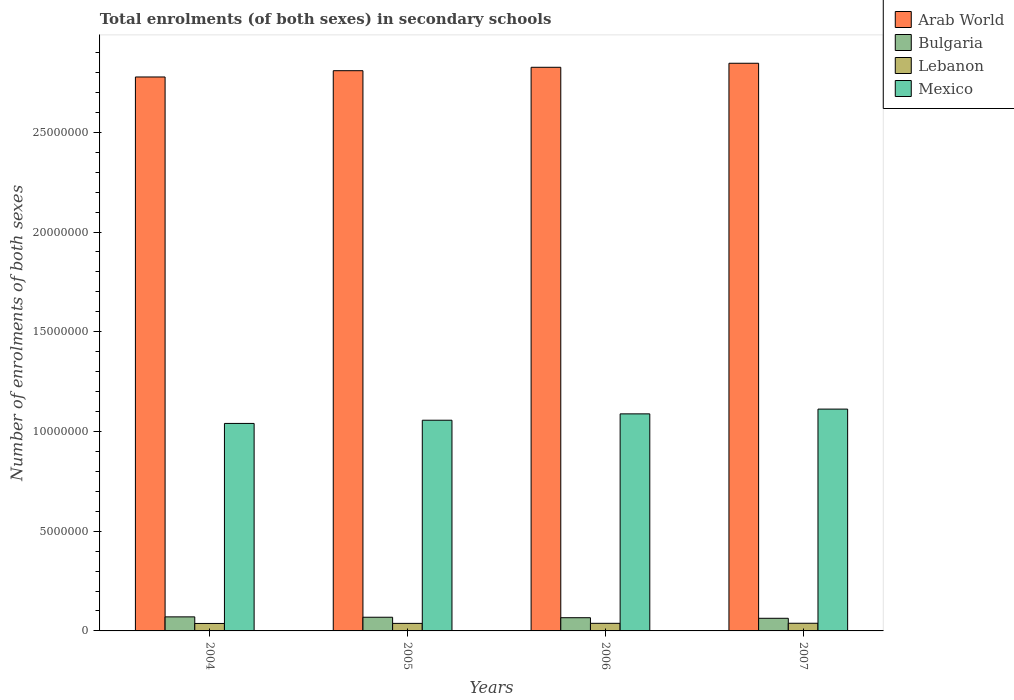How many different coloured bars are there?
Give a very brief answer. 4. How many groups of bars are there?
Ensure brevity in your answer.  4. Are the number of bars per tick equal to the number of legend labels?
Your response must be concise. Yes. What is the number of enrolments in secondary schools in Bulgaria in 2007?
Provide a succinct answer. 6.33e+05. Across all years, what is the maximum number of enrolments in secondary schools in Lebanon?
Your answer should be very brief. 3.84e+05. Across all years, what is the minimum number of enrolments in secondary schools in Lebanon?
Make the answer very short. 3.74e+05. In which year was the number of enrolments in secondary schools in Lebanon maximum?
Provide a short and direct response. 2007. What is the total number of enrolments in secondary schools in Bulgaria in the graph?
Offer a terse response. 2.69e+06. What is the difference between the number of enrolments in secondary schools in Lebanon in 2006 and that in 2007?
Your answer should be compact. -2696. What is the difference between the number of enrolments in secondary schools in Bulgaria in 2007 and the number of enrolments in secondary schools in Arab World in 2004?
Offer a terse response. -2.71e+07. What is the average number of enrolments in secondary schools in Lebanon per year?
Provide a succinct answer. 3.79e+05. In the year 2006, what is the difference between the number of enrolments in secondary schools in Lebanon and number of enrolments in secondary schools in Bulgaria?
Your answer should be compact. -2.81e+05. In how many years, is the number of enrolments in secondary schools in Bulgaria greater than 19000000?
Provide a succinct answer. 0. What is the ratio of the number of enrolments in secondary schools in Arab World in 2004 to that in 2005?
Your answer should be very brief. 0.99. Is the difference between the number of enrolments in secondary schools in Lebanon in 2006 and 2007 greater than the difference between the number of enrolments in secondary schools in Bulgaria in 2006 and 2007?
Make the answer very short. No. What is the difference between the highest and the second highest number of enrolments in secondary schools in Mexico?
Your answer should be very brief. 2.39e+05. What is the difference between the highest and the lowest number of enrolments in secondary schools in Mexico?
Your response must be concise. 7.18e+05. Is it the case that in every year, the sum of the number of enrolments in secondary schools in Arab World and number of enrolments in secondary schools in Bulgaria is greater than the sum of number of enrolments in secondary schools in Mexico and number of enrolments in secondary schools in Lebanon?
Keep it short and to the point. Yes. What does the 1st bar from the right in 2004 represents?
Give a very brief answer. Mexico. What is the difference between two consecutive major ticks on the Y-axis?
Offer a terse response. 5.00e+06. How many legend labels are there?
Your answer should be compact. 4. How are the legend labels stacked?
Provide a succinct answer. Vertical. What is the title of the graph?
Provide a succinct answer. Total enrolments (of both sexes) in secondary schools. Does "Australia" appear as one of the legend labels in the graph?
Keep it short and to the point. No. What is the label or title of the X-axis?
Ensure brevity in your answer.  Years. What is the label or title of the Y-axis?
Give a very brief answer. Number of enrolments of both sexes. What is the Number of enrolments of both sexes in Arab World in 2004?
Your response must be concise. 2.78e+07. What is the Number of enrolments of both sexes in Bulgaria in 2004?
Your response must be concise. 7.05e+05. What is the Number of enrolments of both sexes in Lebanon in 2004?
Provide a succinct answer. 3.74e+05. What is the Number of enrolments of both sexes in Mexico in 2004?
Offer a terse response. 1.04e+07. What is the Number of enrolments of both sexes of Arab World in 2005?
Your response must be concise. 2.81e+07. What is the Number of enrolments of both sexes in Bulgaria in 2005?
Make the answer very short. 6.86e+05. What is the Number of enrolments of both sexes of Lebanon in 2005?
Ensure brevity in your answer.  3.78e+05. What is the Number of enrolments of both sexes in Mexico in 2005?
Offer a terse response. 1.06e+07. What is the Number of enrolments of both sexes of Arab World in 2006?
Your answer should be very brief. 2.83e+07. What is the Number of enrolments of both sexes of Bulgaria in 2006?
Make the answer very short. 6.63e+05. What is the Number of enrolments of both sexes in Lebanon in 2006?
Provide a succinct answer. 3.81e+05. What is the Number of enrolments of both sexes of Mexico in 2006?
Your answer should be compact. 1.09e+07. What is the Number of enrolments of both sexes of Arab World in 2007?
Make the answer very short. 2.85e+07. What is the Number of enrolments of both sexes in Bulgaria in 2007?
Keep it short and to the point. 6.33e+05. What is the Number of enrolments of both sexes in Lebanon in 2007?
Provide a short and direct response. 3.84e+05. What is the Number of enrolments of both sexes in Mexico in 2007?
Provide a short and direct response. 1.11e+07. Across all years, what is the maximum Number of enrolments of both sexes of Arab World?
Make the answer very short. 2.85e+07. Across all years, what is the maximum Number of enrolments of both sexes in Bulgaria?
Give a very brief answer. 7.05e+05. Across all years, what is the maximum Number of enrolments of both sexes in Lebanon?
Ensure brevity in your answer.  3.84e+05. Across all years, what is the maximum Number of enrolments of both sexes in Mexico?
Keep it short and to the point. 1.11e+07. Across all years, what is the minimum Number of enrolments of both sexes of Arab World?
Give a very brief answer. 2.78e+07. Across all years, what is the minimum Number of enrolments of both sexes in Bulgaria?
Ensure brevity in your answer.  6.33e+05. Across all years, what is the minimum Number of enrolments of both sexes of Lebanon?
Offer a terse response. 3.74e+05. Across all years, what is the minimum Number of enrolments of both sexes of Mexico?
Keep it short and to the point. 1.04e+07. What is the total Number of enrolments of both sexes in Arab World in the graph?
Offer a terse response. 1.13e+08. What is the total Number of enrolments of both sexes of Bulgaria in the graph?
Your answer should be very brief. 2.69e+06. What is the total Number of enrolments of both sexes of Lebanon in the graph?
Your answer should be very brief. 1.52e+06. What is the total Number of enrolments of both sexes of Mexico in the graph?
Your answer should be compact. 4.30e+07. What is the difference between the Number of enrolments of both sexes of Arab World in 2004 and that in 2005?
Offer a very short reply. -3.15e+05. What is the difference between the Number of enrolments of both sexes in Bulgaria in 2004 and that in 2005?
Your answer should be compact. 1.90e+04. What is the difference between the Number of enrolments of both sexes in Lebanon in 2004 and that in 2005?
Give a very brief answer. -3838. What is the difference between the Number of enrolments of both sexes in Mexico in 2004 and that in 2005?
Offer a very short reply. -1.61e+05. What is the difference between the Number of enrolments of both sexes of Arab World in 2004 and that in 2006?
Offer a very short reply. -4.86e+05. What is the difference between the Number of enrolments of both sexes in Bulgaria in 2004 and that in 2006?
Provide a succinct answer. 4.22e+04. What is the difference between the Number of enrolments of both sexes in Lebanon in 2004 and that in 2006?
Provide a short and direct response. -7414. What is the difference between the Number of enrolments of both sexes of Mexico in 2004 and that in 2006?
Offer a terse response. -4.80e+05. What is the difference between the Number of enrolments of both sexes of Arab World in 2004 and that in 2007?
Your response must be concise. -6.88e+05. What is the difference between the Number of enrolments of both sexes of Bulgaria in 2004 and that in 2007?
Your response must be concise. 7.13e+04. What is the difference between the Number of enrolments of both sexes of Lebanon in 2004 and that in 2007?
Your response must be concise. -1.01e+04. What is the difference between the Number of enrolments of both sexes in Mexico in 2004 and that in 2007?
Provide a succinct answer. -7.18e+05. What is the difference between the Number of enrolments of both sexes of Arab World in 2005 and that in 2006?
Ensure brevity in your answer.  -1.70e+05. What is the difference between the Number of enrolments of both sexes in Bulgaria in 2005 and that in 2006?
Provide a succinct answer. 2.31e+04. What is the difference between the Number of enrolments of both sexes of Lebanon in 2005 and that in 2006?
Give a very brief answer. -3576. What is the difference between the Number of enrolments of both sexes of Mexico in 2005 and that in 2006?
Ensure brevity in your answer.  -3.19e+05. What is the difference between the Number of enrolments of both sexes of Arab World in 2005 and that in 2007?
Ensure brevity in your answer.  -3.73e+05. What is the difference between the Number of enrolments of both sexes of Bulgaria in 2005 and that in 2007?
Provide a succinct answer. 5.23e+04. What is the difference between the Number of enrolments of both sexes in Lebanon in 2005 and that in 2007?
Keep it short and to the point. -6272. What is the difference between the Number of enrolments of both sexes in Mexico in 2005 and that in 2007?
Your response must be concise. -5.58e+05. What is the difference between the Number of enrolments of both sexes of Arab World in 2006 and that in 2007?
Offer a very short reply. -2.02e+05. What is the difference between the Number of enrolments of both sexes in Bulgaria in 2006 and that in 2007?
Give a very brief answer. 2.92e+04. What is the difference between the Number of enrolments of both sexes of Lebanon in 2006 and that in 2007?
Keep it short and to the point. -2696. What is the difference between the Number of enrolments of both sexes in Mexico in 2006 and that in 2007?
Offer a very short reply. -2.39e+05. What is the difference between the Number of enrolments of both sexes in Arab World in 2004 and the Number of enrolments of both sexes in Bulgaria in 2005?
Your answer should be compact. 2.71e+07. What is the difference between the Number of enrolments of both sexes of Arab World in 2004 and the Number of enrolments of both sexes of Lebanon in 2005?
Make the answer very short. 2.74e+07. What is the difference between the Number of enrolments of both sexes in Arab World in 2004 and the Number of enrolments of both sexes in Mexico in 2005?
Ensure brevity in your answer.  1.72e+07. What is the difference between the Number of enrolments of both sexes in Bulgaria in 2004 and the Number of enrolments of both sexes in Lebanon in 2005?
Your response must be concise. 3.27e+05. What is the difference between the Number of enrolments of both sexes of Bulgaria in 2004 and the Number of enrolments of both sexes of Mexico in 2005?
Offer a terse response. -9.86e+06. What is the difference between the Number of enrolments of both sexes of Lebanon in 2004 and the Number of enrolments of both sexes of Mexico in 2005?
Keep it short and to the point. -1.02e+07. What is the difference between the Number of enrolments of both sexes in Arab World in 2004 and the Number of enrolments of both sexes in Bulgaria in 2006?
Offer a very short reply. 2.71e+07. What is the difference between the Number of enrolments of both sexes of Arab World in 2004 and the Number of enrolments of both sexes of Lebanon in 2006?
Your answer should be very brief. 2.74e+07. What is the difference between the Number of enrolments of both sexes of Arab World in 2004 and the Number of enrolments of both sexes of Mexico in 2006?
Offer a terse response. 1.69e+07. What is the difference between the Number of enrolments of both sexes of Bulgaria in 2004 and the Number of enrolments of both sexes of Lebanon in 2006?
Give a very brief answer. 3.23e+05. What is the difference between the Number of enrolments of both sexes in Bulgaria in 2004 and the Number of enrolments of both sexes in Mexico in 2006?
Offer a very short reply. -1.02e+07. What is the difference between the Number of enrolments of both sexes of Lebanon in 2004 and the Number of enrolments of both sexes of Mexico in 2006?
Give a very brief answer. -1.05e+07. What is the difference between the Number of enrolments of both sexes of Arab World in 2004 and the Number of enrolments of both sexes of Bulgaria in 2007?
Give a very brief answer. 2.71e+07. What is the difference between the Number of enrolments of both sexes in Arab World in 2004 and the Number of enrolments of both sexes in Lebanon in 2007?
Your response must be concise. 2.74e+07. What is the difference between the Number of enrolments of both sexes in Arab World in 2004 and the Number of enrolments of both sexes in Mexico in 2007?
Your answer should be compact. 1.67e+07. What is the difference between the Number of enrolments of both sexes of Bulgaria in 2004 and the Number of enrolments of both sexes of Lebanon in 2007?
Ensure brevity in your answer.  3.21e+05. What is the difference between the Number of enrolments of both sexes in Bulgaria in 2004 and the Number of enrolments of both sexes in Mexico in 2007?
Offer a terse response. -1.04e+07. What is the difference between the Number of enrolments of both sexes of Lebanon in 2004 and the Number of enrolments of both sexes of Mexico in 2007?
Provide a succinct answer. -1.07e+07. What is the difference between the Number of enrolments of both sexes of Arab World in 2005 and the Number of enrolments of both sexes of Bulgaria in 2006?
Your response must be concise. 2.74e+07. What is the difference between the Number of enrolments of both sexes of Arab World in 2005 and the Number of enrolments of both sexes of Lebanon in 2006?
Your answer should be very brief. 2.77e+07. What is the difference between the Number of enrolments of both sexes of Arab World in 2005 and the Number of enrolments of both sexes of Mexico in 2006?
Your answer should be very brief. 1.72e+07. What is the difference between the Number of enrolments of both sexes of Bulgaria in 2005 and the Number of enrolments of both sexes of Lebanon in 2006?
Ensure brevity in your answer.  3.04e+05. What is the difference between the Number of enrolments of both sexes of Bulgaria in 2005 and the Number of enrolments of both sexes of Mexico in 2006?
Offer a terse response. -1.02e+07. What is the difference between the Number of enrolments of both sexes of Lebanon in 2005 and the Number of enrolments of both sexes of Mexico in 2006?
Offer a terse response. -1.05e+07. What is the difference between the Number of enrolments of both sexes in Arab World in 2005 and the Number of enrolments of both sexes in Bulgaria in 2007?
Your answer should be compact. 2.75e+07. What is the difference between the Number of enrolments of both sexes in Arab World in 2005 and the Number of enrolments of both sexes in Lebanon in 2007?
Provide a succinct answer. 2.77e+07. What is the difference between the Number of enrolments of both sexes of Arab World in 2005 and the Number of enrolments of both sexes of Mexico in 2007?
Your answer should be compact. 1.70e+07. What is the difference between the Number of enrolments of both sexes of Bulgaria in 2005 and the Number of enrolments of both sexes of Lebanon in 2007?
Give a very brief answer. 3.01e+05. What is the difference between the Number of enrolments of both sexes in Bulgaria in 2005 and the Number of enrolments of both sexes in Mexico in 2007?
Make the answer very short. -1.04e+07. What is the difference between the Number of enrolments of both sexes in Lebanon in 2005 and the Number of enrolments of both sexes in Mexico in 2007?
Make the answer very short. -1.07e+07. What is the difference between the Number of enrolments of both sexes of Arab World in 2006 and the Number of enrolments of both sexes of Bulgaria in 2007?
Your response must be concise. 2.76e+07. What is the difference between the Number of enrolments of both sexes of Arab World in 2006 and the Number of enrolments of both sexes of Lebanon in 2007?
Offer a terse response. 2.79e+07. What is the difference between the Number of enrolments of both sexes in Arab World in 2006 and the Number of enrolments of both sexes in Mexico in 2007?
Make the answer very short. 1.71e+07. What is the difference between the Number of enrolments of both sexes of Bulgaria in 2006 and the Number of enrolments of both sexes of Lebanon in 2007?
Your answer should be compact. 2.78e+05. What is the difference between the Number of enrolments of both sexes in Bulgaria in 2006 and the Number of enrolments of both sexes in Mexico in 2007?
Ensure brevity in your answer.  -1.05e+07. What is the difference between the Number of enrolments of both sexes of Lebanon in 2006 and the Number of enrolments of both sexes of Mexico in 2007?
Provide a succinct answer. -1.07e+07. What is the average Number of enrolments of both sexes in Arab World per year?
Ensure brevity in your answer.  2.81e+07. What is the average Number of enrolments of both sexes of Bulgaria per year?
Offer a very short reply. 6.72e+05. What is the average Number of enrolments of both sexes in Lebanon per year?
Your answer should be compact. 3.79e+05. What is the average Number of enrolments of both sexes in Mexico per year?
Provide a succinct answer. 1.07e+07. In the year 2004, what is the difference between the Number of enrolments of both sexes of Arab World and Number of enrolments of both sexes of Bulgaria?
Ensure brevity in your answer.  2.71e+07. In the year 2004, what is the difference between the Number of enrolments of both sexes of Arab World and Number of enrolments of both sexes of Lebanon?
Your answer should be very brief. 2.74e+07. In the year 2004, what is the difference between the Number of enrolments of both sexes of Arab World and Number of enrolments of both sexes of Mexico?
Your answer should be very brief. 1.74e+07. In the year 2004, what is the difference between the Number of enrolments of both sexes in Bulgaria and Number of enrolments of both sexes in Lebanon?
Provide a succinct answer. 3.31e+05. In the year 2004, what is the difference between the Number of enrolments of both sexes in Bulgaria and Number of enrolments of both sexes in Mexico?
Your answer should be very brief. -9.70e+06. In the year 2004, what is the difference between the Number of enrolments of both sexes in Lebanon and Number of enrolments of both sexes in Mexico?
Provide a succinct answer. -1.00e+07. In the year 2005, what is the difference between the Number of enrolments of both sexes of Arab World and Number of enrolments of both sexes of Bulgaria?
Offer a terse response. 2.74e+07. In the year 2005, what is the difference between the Number of enrolments of both sexes of Arab World and Number of enrolments of both sexes of Lebanon?
Offer a very short reply. 2.77e+07. In the year 2005, what is the difference between the Number of enrolments of both sexes of Arab World and Number of enrolments of both sexes of Mexico?
Offer a very short reply. 1.75e+07. In the year 2005, what is the difference between the Number of enrolments of both sexes of Bulgaria and Number of enrolments of both sexes of Lebanon?
Offer a very short reply. 3.08e+05. In the year 2005, what is the difference between the Number of enrolments of both sexes in Bulgaria and Number of enrolments of both sexes in Mexico?
Offer a terse response. -9.88e+06. In the year 2005, what is the difference between the Number of enrolments of both sexes of Lebanon and Number of enrolments of both sexes of Mexico?
Keep it short and to the point. -1.02e+07. In the year 2006, what is the difference between the Number of enrolments of both sexes of Arab World and Number of enrolments of both sexes of Bulgaria?
Your answer should be very brief. 2.76e+07. In the year 2006, what is the difference between the Number of enrolments of both sexes of Arab World and Number of enrolments of both sexes of Lebanon?
Ensure brevity in your answer.  2.79e+07. In the year 2006, what is the difference between the Number of enrolments of both sexes in Arab World and Number of enrolments of both sexes in Mexico?
Provide a short and direct response. 1.74e+07. In the year 2006, what is the difference between the Number of enrolments of both sexes in Bulgaria and Number of enrolments of both sexes in Lebanon?
Provide a short and direct response. 2.81e+05. In the year 2006, what is the difference between the Number of enrolments of both sexes in Bulgaria and Number of enrolments of both sexes in Mexico?
Your answer should be very brief. -1.02e+07. In the year 2006, what is the difference between the Number of enrolments of both sexes of Lebanon and Number of enrolments of both sexes of Mexico?
Make the answer very short. -1.05e+07. In the year 2007, what is the difference between the Number of enrolments of both sexes of Arab World and Number of enrolments of both sexes of Bulgaria?
Your answer should be very brief. 2.78e+07. In the year 2007, what is the difference between the Number of enrolments of both sexes in Arab World and Number of enrolments of both sexes in Lebanon?
Provide a short and direct response. 2.81e+07. In the year 2007, what is the difference between the Number of enrolments of both sexes in Arab World and Number of enrolments of both sexes in Mexico?
Ensure brevity in your answer.  1.73e+07. In the year 2007, what is the difference between the Number of enrolments of both sexes of Bulgaria and Number of enrolments of both sexes of Lebanon?
Make the answer very short. 2.49e+05. In the year 2007, what is the difference between the Number of enrolments of both sexes of Bulgaria and Number of enrolments of both sexes of Mexico?
Offer a very short reply. -1.05e+07. In the year 2007, what is the difference between the Number of enrolments of both sexes in Lebanon and Number of enrolments of both sexes in Mexico?
Your answer should be compact. -1.07e+07. What is the ratio of the Number of enrolments of both sexes of Bulgaria in 2004 to that in 2005?
Ensure brevity in your answer.  1.03. What is the ratio of the Number of enrolments of both sexes of Lebanon in 2004 to that in 2005?
Keep it short and to the point. 0.99. What is the ratio of the Number of enrolments of both sexes in Arab World in 2004 to that in 2006?
Keep it short and to the point. 0.98. What is the ratio of the Number of enrolments of both sexes of Bulgaria in 2004 to that in 2006?
Give a very brief answer. 1.06. What is the ratio of the Number of enrolments of both sexes in Lebanon in 2004 to that in 2006?
Make the answer very short. 0.98. What is the ratio of the Number of enrolments of both sexes in Mexico in 2004 to that in 2006?
Offer a terse response. 0.96. What is the ratio of the Number of enrolments of both sexes in Arab World in 2004 to that in 2007?
Give a very brief answer. 0.98. What is the ratio of the Number of enrolments of both sexes in Bulgaria in 2004 to that in 2007?
Ensure brevity in your answer.  1.11. What is the ratio of the Number of enrolments of both sexes of Lebanon in 2004 to that in 2007?
Offer a very short reply. 0.97. What is the ratio of the Number of enrolments of both sexes in Mexico in 2004 to that in 2007?
Give a very brief answer. 0.94. What is the ratio of the Number of enrolments of both sexes in Arab World in 2005 to that in 2006?
Offer a terse response. 0.99. What is the ratio of the Number of enrolments of both sexes in Bulgaria in 2005 to that in 2006?
Keep it short and to the point. 1.03. What is the ratio of the Number of enrolments of both sexes of Lebanon in 2005 to that in 2006?
Your response must be concise. 0.99. What is the ratio of the Number of enrolments of both sexes in Mexico in 2005 to that in 2006?
Ensure brevity in your answer.  0.97. What is the ratio of the Number of enrolments of both sexes in Arab World in 2005 to that in 2007?
Your answer should be very brief. 0.99. What is the ratio of the Number of enrolments of both sexes of Bulgaria in 2005 to that in 2007?
Give a very brief answer. 1.08. What is the ratio of the Number of enrolments of both sexes in Lebanon in 2005 to that in 2007?
Provide a succinct answer. 0.98. What is the ratio of the Number of enrolments of both sexes in Mexico in 2005 to that in 2007?
Provide a succinct answer. 0.95. What is the ratio of the Number of enrolments of both sexes in Arab World in 2006 to that in 2007?
Offer a very short reply. 0.99. What is the ratio of the Number of enrolments of both sexes in Bulgaria in 2006 to that in 2007?
Ensure brevity in your answer.  1.05. What is the ratio of the Number of enrolments of both sexes in Mexico in 2006 to that in 2007?
Your answer should be very brief. 0.98. What is the difference between the highest and the second highest Number of enrolments of both sexes of Arab World?
Provide a succinct answer. 2.02e+05. What is the difference between the highest and the second highest Number of enrolments of both sexes in Bulgaria?
Provide a short and direct response. 1.90e+04. What is the difference between the highest and the second highest Number of enrolments of both sexes in Lebanon?
Offer a very short reply. 2696. What is the difference between the highest and the second highest Number of enrolments of both sexes in Mexico?
Your answer should be compact. 2.39e+05. What is the difference between the highest and the lowest Number of enrolments of both sexes of Arab World?
Your response must be concise. 6.88e+05. What is the difference between the highest and the lowest Number of enrolments of both sexes of Bulgaria?
Provide a succinct answer. 7.13e+04. What is the difference between the highest and the lowest Number of enrolments of both sexes of Lebanon?
Provide a succinct answer. 1.01e+04. What is the difference between the highest and the lowest Number of enrolments of both sexes of Mexico?
Provide a succinct answer. 7.18e+05. 